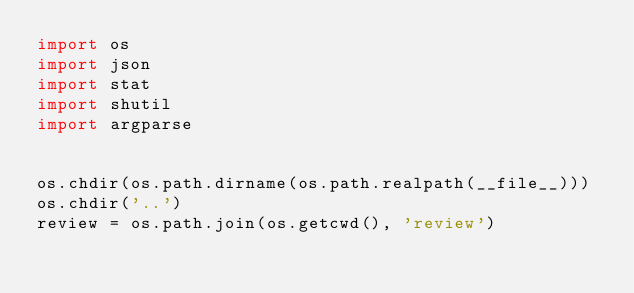<code> <loc_0><loc_0><loc_500><loc_500><_Python_>import os
import json
import stat
import shutil
import argparse


os.chdir(os.path.dirname(os.path.realpath(__file__)))
os.chdir('..')
review = os.path.join(os.getcwd(), 'review')
</code> 